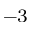Convert formula to latex. <formula><loc_0><loc_0><loc_500><loc_500>^ { - 3 }</formula> 